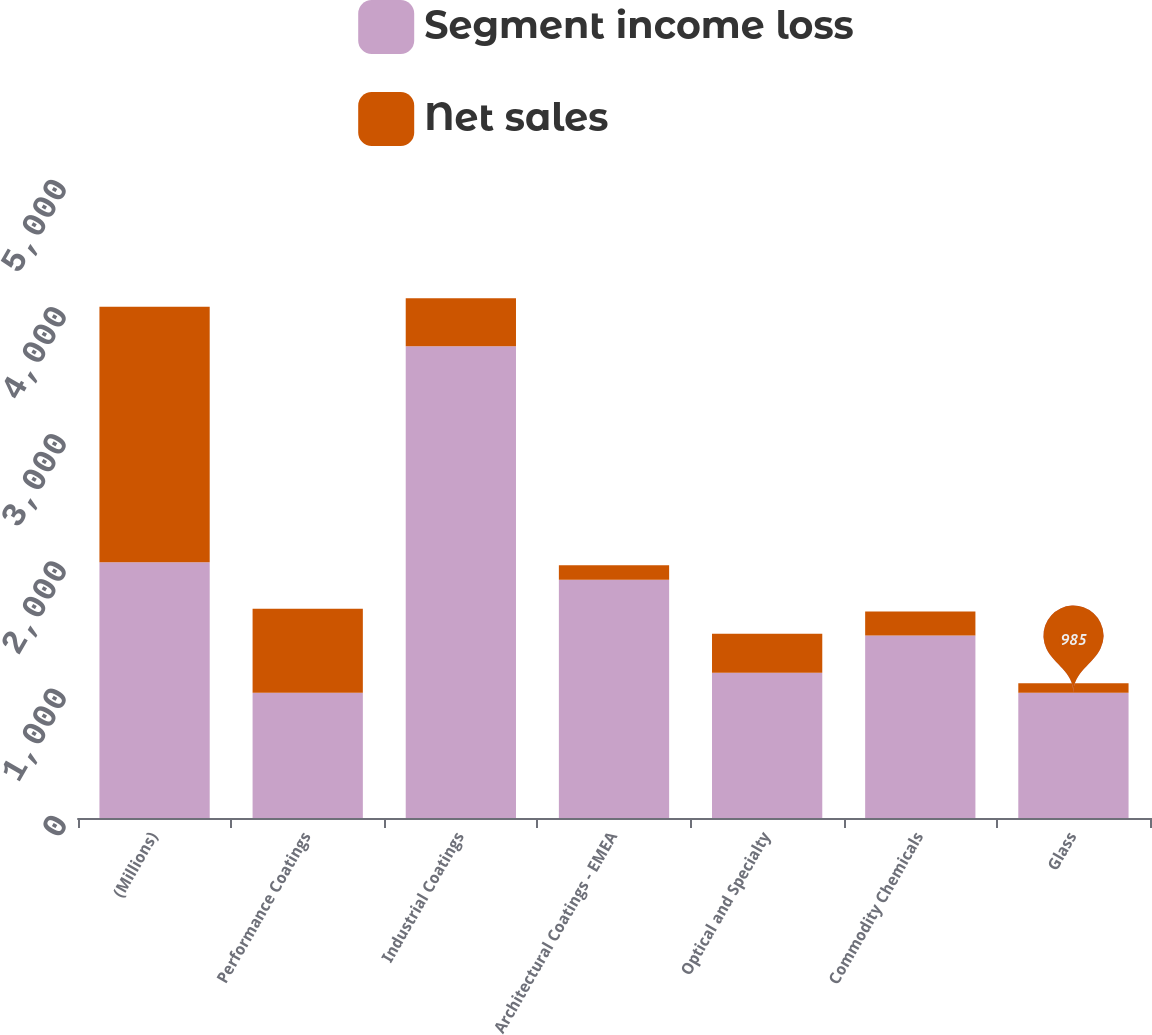<chart> <loc_0><loc_0><loc_500><loc_500><stacked_bar_chart><ecel><fcel>(Millions)<fcel>Performance Coatings<fcel>Industrial Coatings<fcel>Architectural Coatings - EMEA<fcel>Optical and Specialty<fcel>Commodity Chemicals<fcel>Glass<nl><fcel>Segment income loss<fcel>2010<fcel>985<fcel>3708<fcel>1874<fcel>1141<fcel>1434<fcel>985<nl><fcel>Net sales<fcel>2010<fcel>661<fcel>378<fcel>113<fcel>307<fcel>189<fcel>74<nl></chart> 